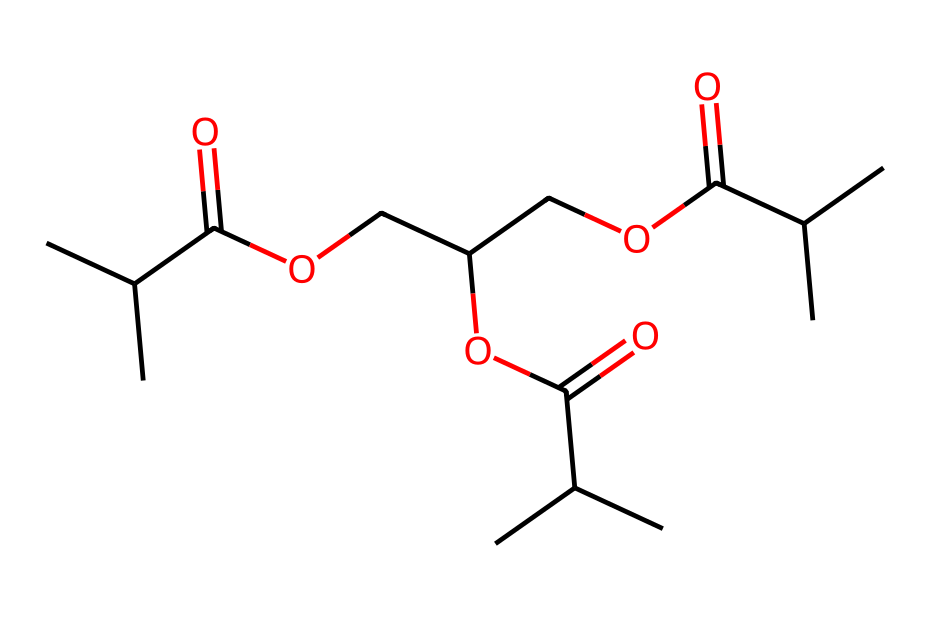What type of functional groups are present in this structure? The structure contains ester groups, which are characterized by the presence of a carbonyl (C=O) adjacent to an ether or alkoxy group (C-O). The repeated instances of the -C(=O)O- segment indicate ester functionalities.
Answer: ester How many carbon atoms are in the molecule represented by the SMILES? By examining the structure and counting each carbon atom represented in the molecular framework, there are a total of 18 carbon atoms indicated in the SMILES notation.
Answer: 18 Does this chemical structure indicate it is biodegradable? Yes, the presence of ester linkages and the specific arrangement indicate that it can be hydrolyzed by environmental conditions, making it suitable for biodegradation.
Answer: Yes What is the total number of oxygen atoms in this chemical structure? The SMILES structure displays a total of 6 oxygen atoms, which can be counted by identifying each 'O' present in the representation.
Answer: 6 Can this molecule potentially be used for making eco-friendly toys? Yes, the biodegradable characteristics, along with the non-toxic synthetic pathway typical of these types of polyesters, suggest its suitability for eco-friendly products.
Answer: Yes 